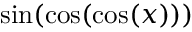<formula> <loc_0><loc_0><loc_500><loc_500>\sin ( \cos ( \cos ( x ) ) )</formula> 